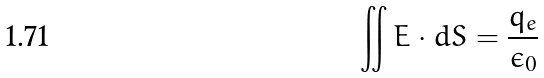<formula> <loc_0><loc_0><loc_500><loc_500>\iint E \cdot d S = \frac { q _ { e } } { \epsilon _ { 0 } }</formula> 